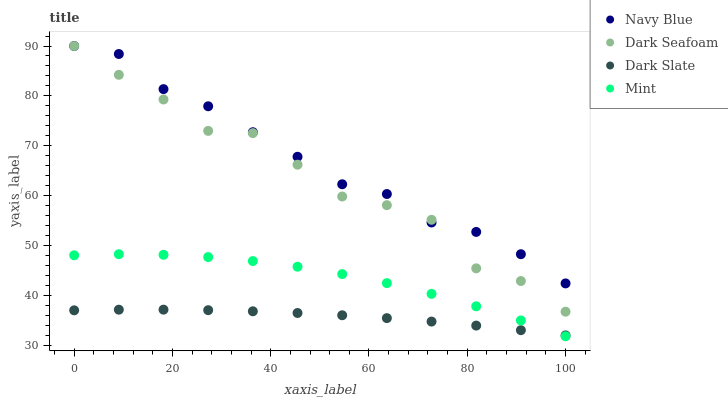Does Dark Slate have the minimum area under the curve?
Answer yes or no. Yes. Does Navy Blue have the maximum area under the curve?
Answer yes or no. Yes. Does Dark Seafoam have the minimum area under the curve?
Answer yes or no. No. Does Dark Seafoam have the maximum area under the curve?
Answer yes or no. No. Is Dark Slate the smoothest?
Answer yes or no. Yes. Is Dark Seafoam the roughest?
Answer yes or no. Yes. Is Mint the smoothest?
Answer yes or no. No. Is Mint the roughest?
Answer yes or no. No. Does Mint have the lowest value?
Answer yes or no. Yes. Does Dark Seafoam have the lowest value?
Answer yes or no. No. Does Dark Seafoam have the highest value?
Answer yes or no. Yes. Does Mint have the highest value?
Answer yes or no. No. Is Dark Slate less than Navy Blue?
Answer yes or no. Yes. Is Dark Seafoam greater than Mint?
Answer yes or no. Yes. Does Dark Seafoam intersect Navy Blue?
Answer yes or no. Yes. Is Dark Seafoam less than Navy Blue?
Answer yes or no. No. Is Dark Seafoam greater than Navy Blue?
Answer yes or no. No. Does Dark Slate intersect Navy Blue?
Answer yes or no. No. 